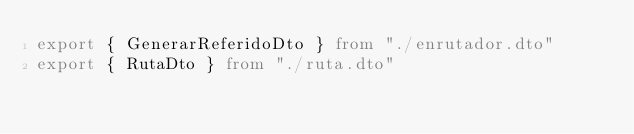Convert code to text. <code><loc_0><loc_0><loc_500><loc_500><_TypeScript_>export { GenerarReferidoDto } from "./enrutador.dto"
export { RutaDto } from "./ruta.dto"</code> 